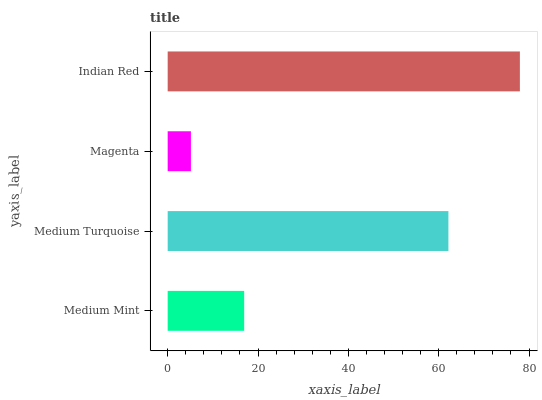Is Magenta the minimum?
Answer yes or no. Yes. Is Indian Red the maximum?
Answer yes or no. Yes. Is Medium Turquoise the minimum?
Answer yes or no. No. Is Medium Turquoise the maximum?
Answer yes or no. No. Is Medium Turquoise greater than Medium Mint?
Answer yes or no. Yes. Is Medium Mint less than Medium Turquoise?
Answer yes or no. Yes. Is Medium Mint greater than Medium Turquoise?
Answer yes or no. No. Is Medium Turquoise less than Medium Mint?
Answer yes or no. No. Is Medium Turquoise the high median?
Answer yes or no. Yes. Is Medium Mint the low median?
Answer yes or no. Yes. Is Indian Red the high median?
Answer yes or no. No. Is Indian Red the low median?
Answer yes or no. No. 